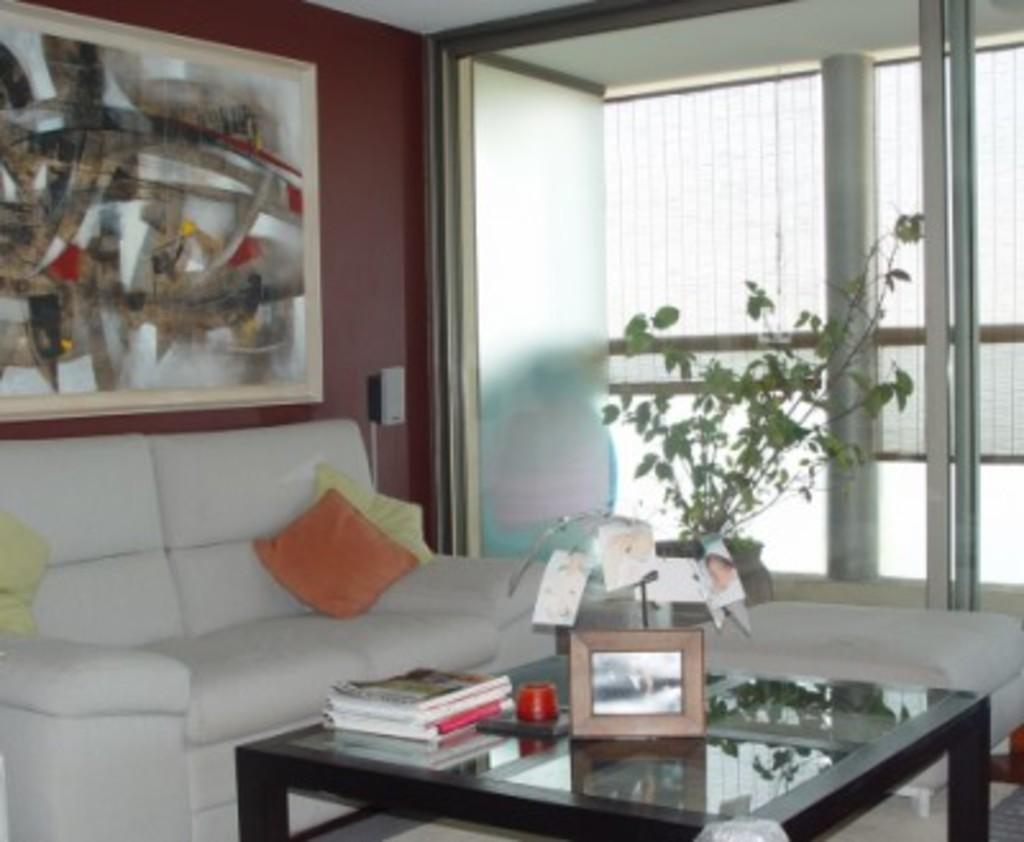What type of furniture is present in the image? There is a couch and a table in the image. What is placed on the table? Objects are placed on the table. What can be seen on the wall? There is a frame on the wall. Is there any greenery in the image? Yes, there is a potted plant is present in the image. Absurd Question/Answer: How many spiders are crawling on the couch in the image? There are no spiders present in the image, so we cannot answer the question about their number or location. 